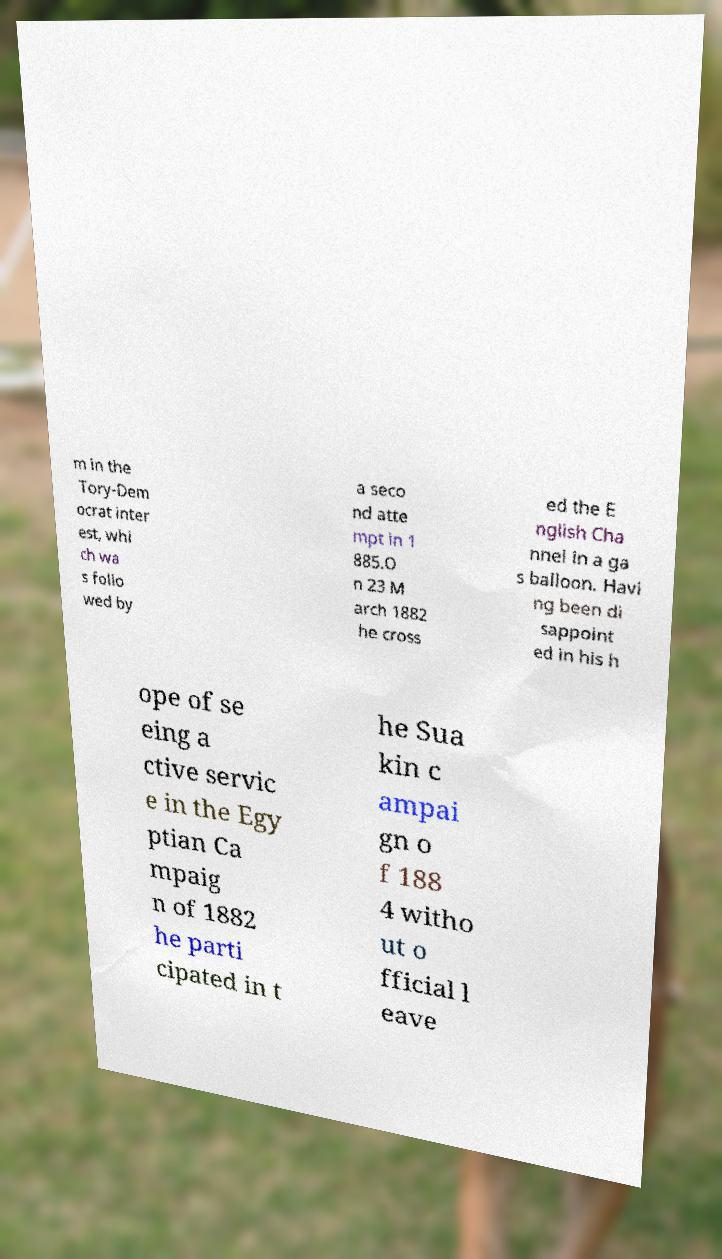Can you accurately transcribe the text from the provided image for me? m in the Tory-Dem ocrat inter est, whi ch wa s follo wed by a seco nd atte mpt in 1 885.O n 23 M arch 1882 he cross ed the E nglish Cha nnel in a ga s balloon. Havi ng been di sappoint ed in his h ope of se eing a ctive servic e in the Egy ptian Ca mpaig n of 1882 he parti cipated in t he Sua kin c ampai gn o f 188 4 witho ut o fficial l eave 